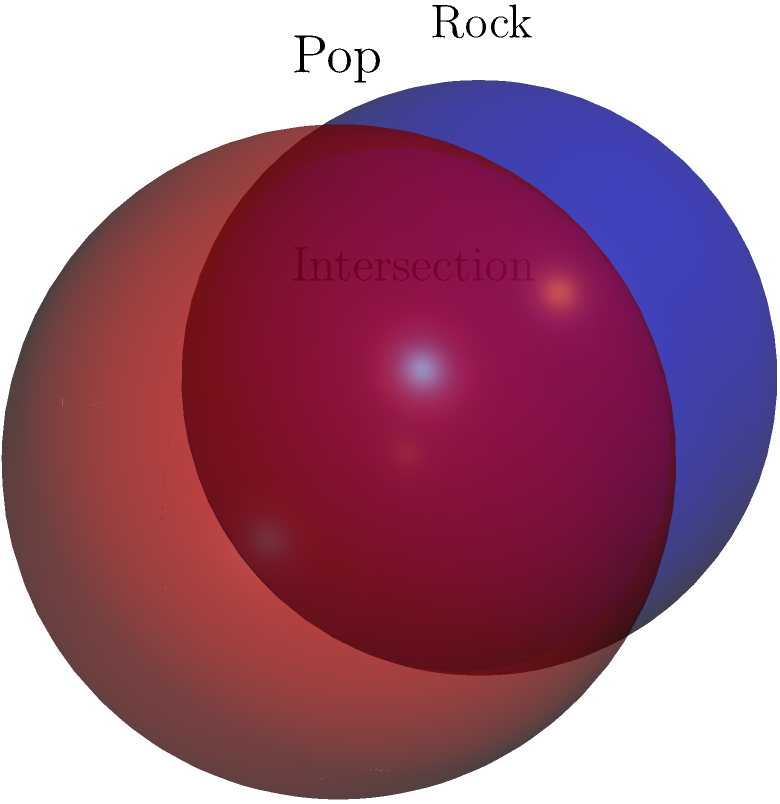In the diagram, two spheres represent the influence of rock and pop music on social movements. The blue sphere represents rock, and the red sphere represents pop. If each sphere has a radius of 1 unit and their centers are 1 unit apart, what is the volume of the intersection between these two musical genres' spheres of influence? To find the volume of intersection between two spheres, we can follow these steps:

1) The volume of intersection for two spheres is given by the formula:
   $$V = \frac{\pi}{12}(4+d)(2-d)^2$$
   where $d$ is the distance between the centers divided by the radius.

2) In this case, the distance between centers is 1 unit, and the radius is also 1 unit.
   So, $d = 1/1 = 1$

3) Substituting $d=1$ into the formula:
   $$V = \frac{\pi}{12}(4+1)(2-1)^2$$

4) Simplify:
   $$V = \frac{\pi}{12}(5)(1)^2 = \frac{5\pi}{12}$$

5) This can be further simplified to:
   $$V = \frac{5\pi}{12} \approx 1.309$$

The volume of intersection represents the overlap of influence between rock and pop music on social movements.
Answer: $\frac{5\pi}{12}$ cubic units 